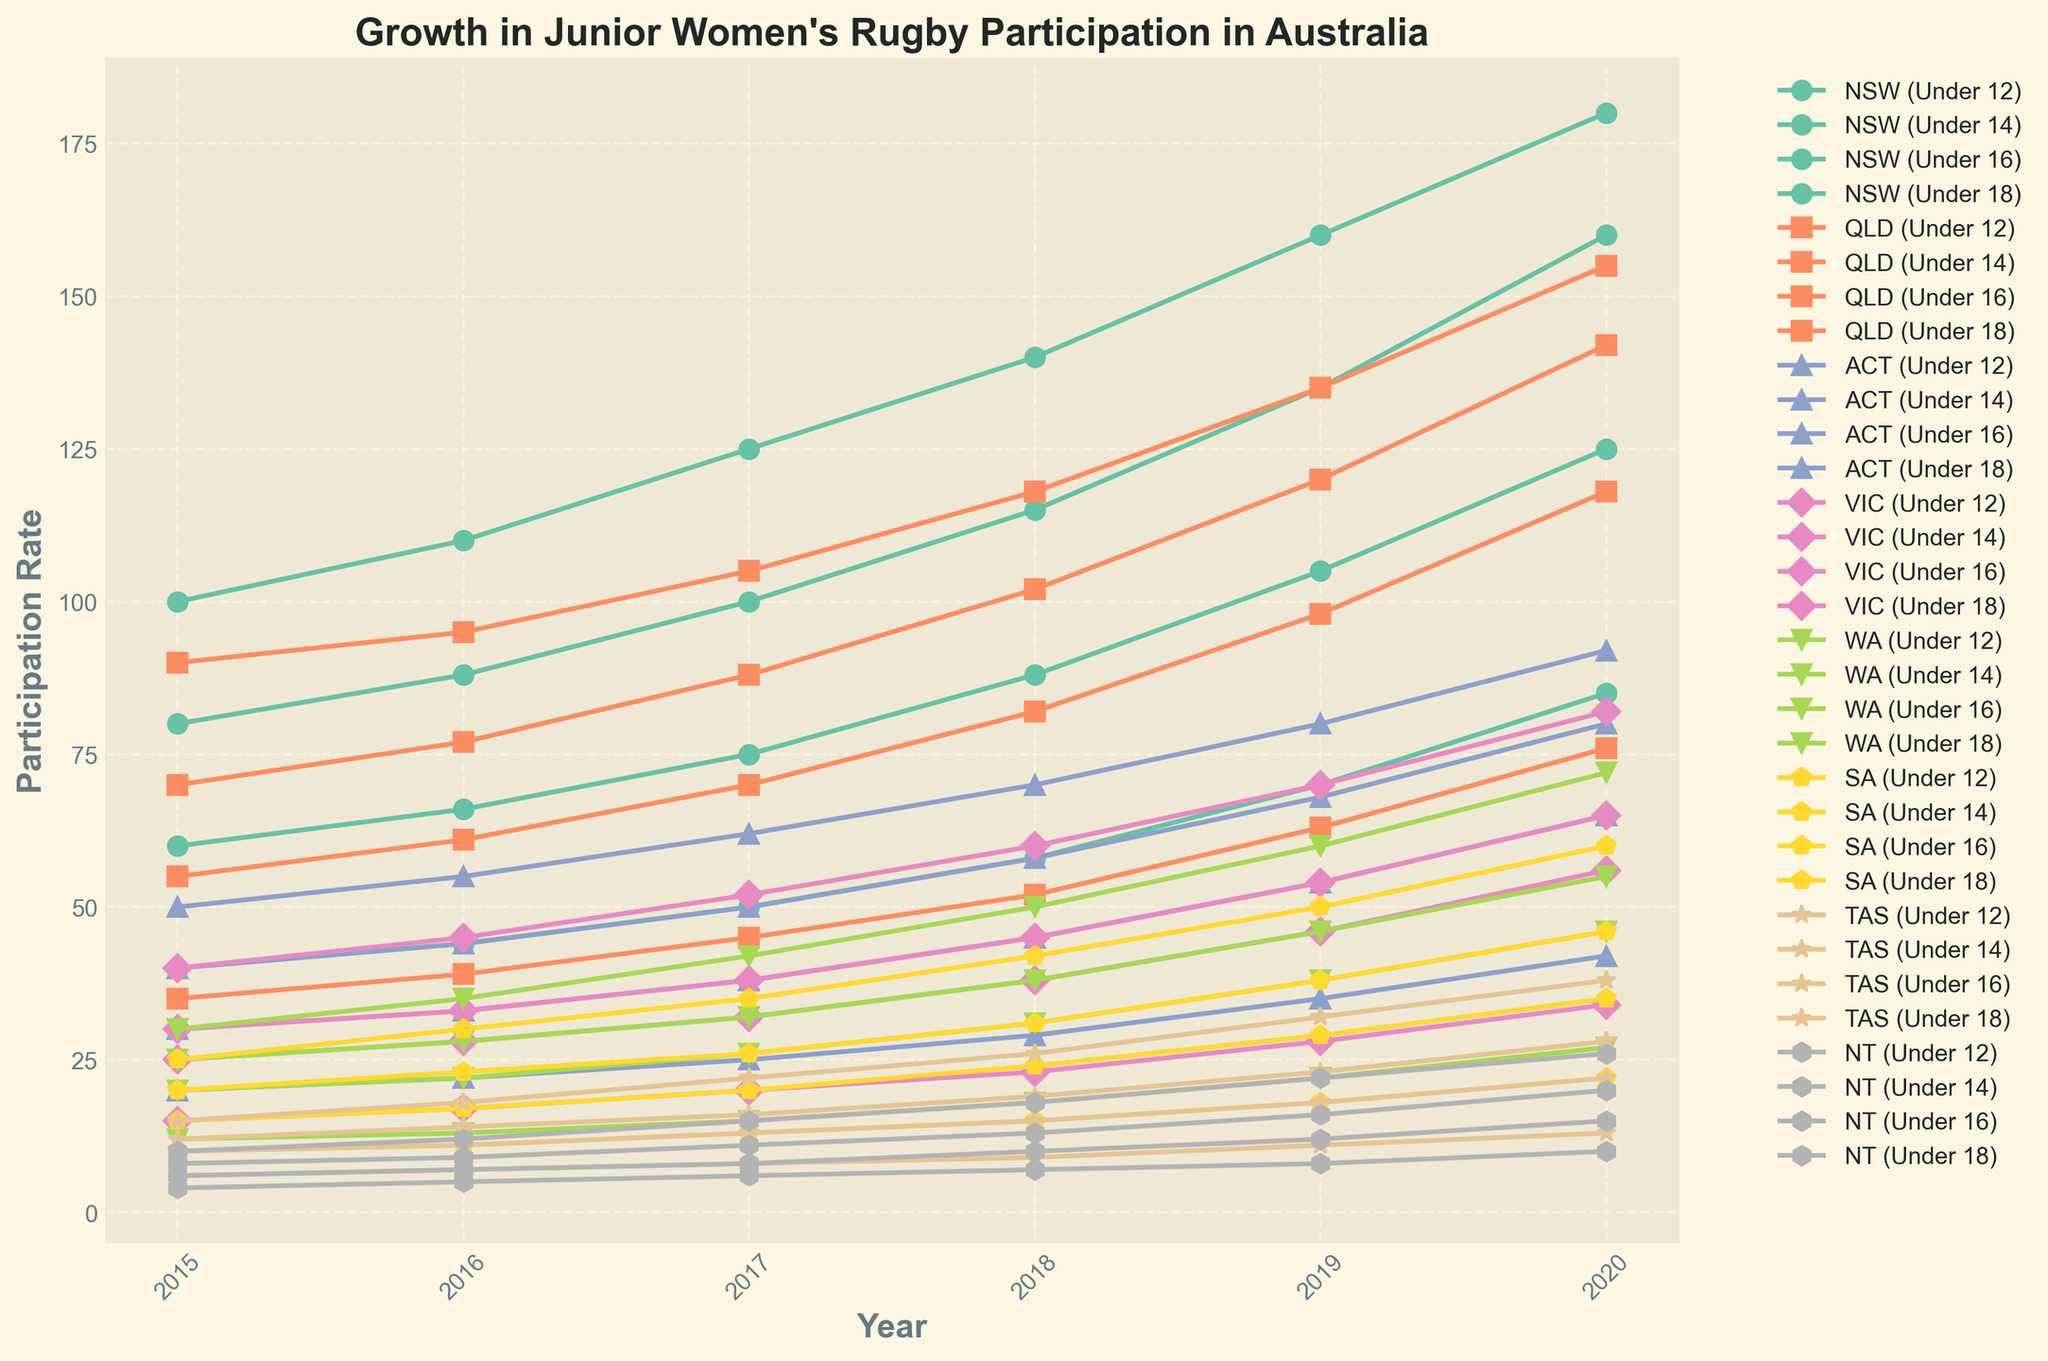Which state shows the highest participation rate growth for the 'Under 12' age group from 2015 to 2020? First, identify the participation rates for the 'Under 12' age group in 2015 and 2020. Then, calculate the growth for each state by subtracting the 2015 value from the 2020 value. Finally, compare the growth values for all states to determine the highest growth.
Answer: NSW Which age group in Queensland (QLD) had the highest participation rate in 2020? Locate the participation rates for all age groups in Queensland (QLD) for the year 2020. Compare these values to determine which age group has the highest participation rate.
Answer: Under 12 Which state had the lowest participation rate for the 'Under 18' age group in 2017? Identify the participation rates for the 'Under 18' age group in all states for the year 2017. Find the minimum value among these rates to determine the state with the lowest participation.
Answer: NT What is the overall trend in participation rates for the 'Under 16' age group in Victoria (VIC) from 2015 to 2020? Check the participation rates for the 'Under 16' age group in Victoria (VIC) for each year from 2015 to 2020 and observe the changes. Describe whether the trend is increasing, decreasing, or stable.
Answer: Increasing How much did the participation rate for the 'Under 14' age group in South Australia (SA) increase from 2015 to 2020? Find the participation rate for the 'Under 14' age group in South Australia (SA) for the years 2015 and 2020. Subtract the 2015 value from the 2020 value to determine the increase.
Answer: 26 Which age group in New South Wales (NSW) had the fastest growth rate from 2015 to 2020? Calculate the growth for each age group in New South Wales (NSW) by subtracting the 2015 value from the 2020 value for each group. Compare these growth values to find the fastest growth.
Answer: Under 12 What is the range of participation rates for the 'Under 14' age group in all states in 2020? Identify the participation rates for the 'Under 14' age group in all states for the year 2020. Calculate the range by subtracting the minimum value from the maximum value.
Answer: 134 Which age group consistently had the lowest participation rates across most states from 2015 to 2020? For each age group, compare the participation rates across most states from 2015 to 2020. Identify the age group that consistently has the lowest values over these years.
Answer: Under 18 What was the participation rate in the Northern Territory (NT) for 'Under 12' in 2015 and how did it compare to the 'Under 16' rate in 2020? Find the participation rates in Northern Territory (NT) for the 'Under 12' age group in 2015 and the 'Under 16' age group in 2020. Compare these values to determine which one is higher.
Answer: 10 (Under 12), 15 (Under 16) How did the participation rate for the 'Under 12' age group in Western Australia (WA) change from 2019 to 2020? Locate the participation rates for the 'Under 12' age group in Western Australia (WA) for the years 2019 and 2020. Subtract the 2019 value from the 2020 value to determine the change.
Answer: 12 